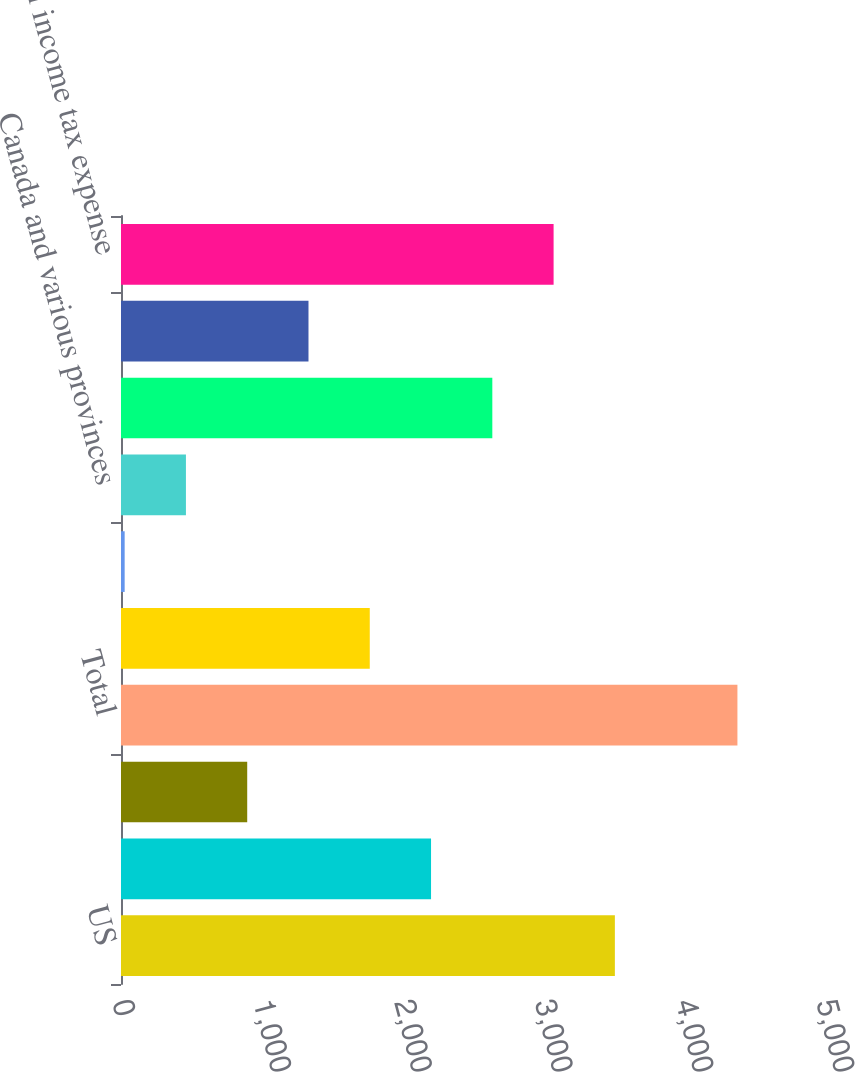Convert chart to OTSL. <chart><loc_0><loc_0><loc_500><loc_500><bar_chart><fcel>US<fcel>Canada<fcel>International<fcel>Total<fcel>US federal<fcel>Various states<fcel>Canada and various provinces<fcel>Total current tax expense<fcel>Total deferred tax expense<fcel>Total income tax expense<nl><fcel>3507.6<fcel>2202<fcel>896.4<fcel>4378<fcel>1766.8<fcel>26<fcel>461.2<fcel>2637.2<fcel>1331.6<fcel>3072.4<nl></chart> 